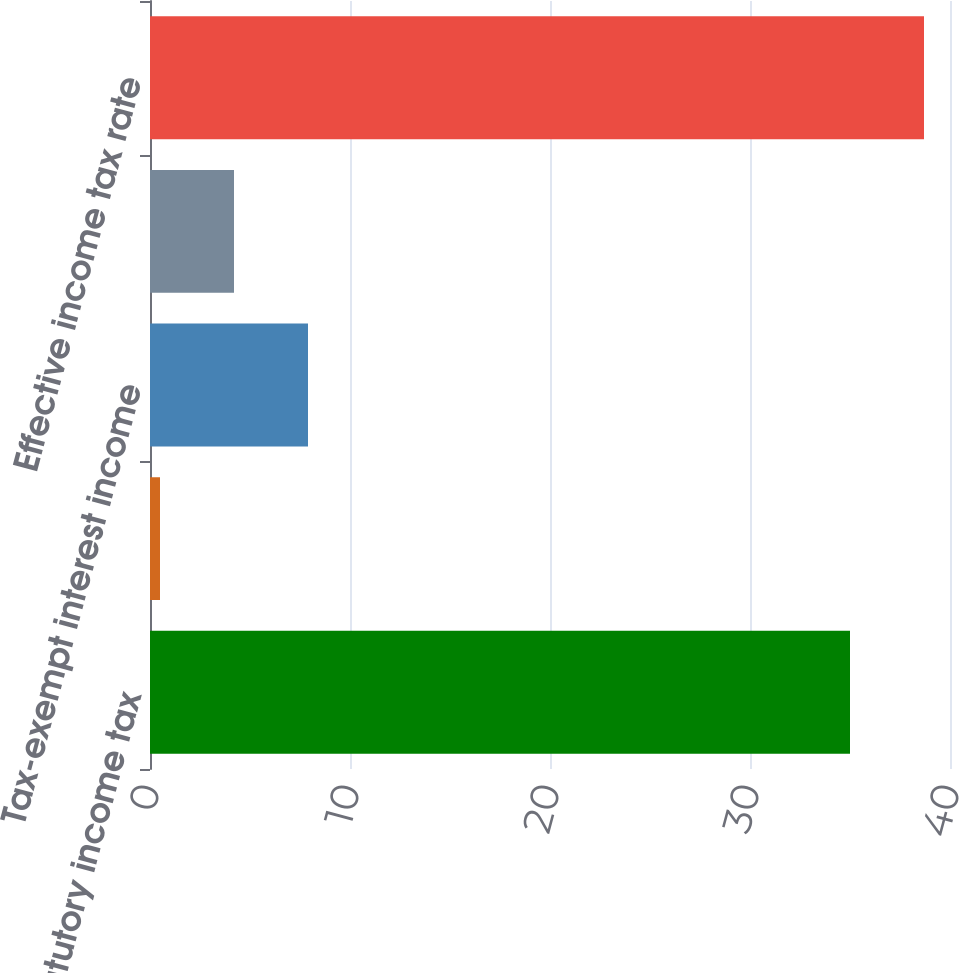<chart> <loc_0><loc_0><loc_500><loc_500><bar_chart><fcel>Federal statutory income tax<fcel>Meals and entertainment<fcel>Tax-exempt interest income<fcel>Low-income housing tax credit<fcel>Effective income tax rate<nl><fcel>35<fcel>0.5<fcel>7.9<fcel>4.2<fcel>38.7<nl></chart> 